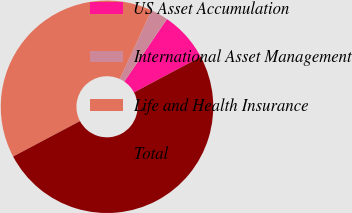Convert chart. <chart><loc_0><loc_0><loc_500><loc_500><pie_chart><fcel>US Asset Accumulation<fcel>International Asset Management<fcel>Life and Health Insurance<fcel>Total<nl><fcel>7.67%<fcel>2.66%<fcel>39.64%<fcel>50.03%<nl></chart> 